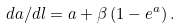<formula> <loc_0><loc_0><loc_500><loc_500>d a / d l = a + \beta \left ( 1 - e ^ { a } \right ) .</formula> 